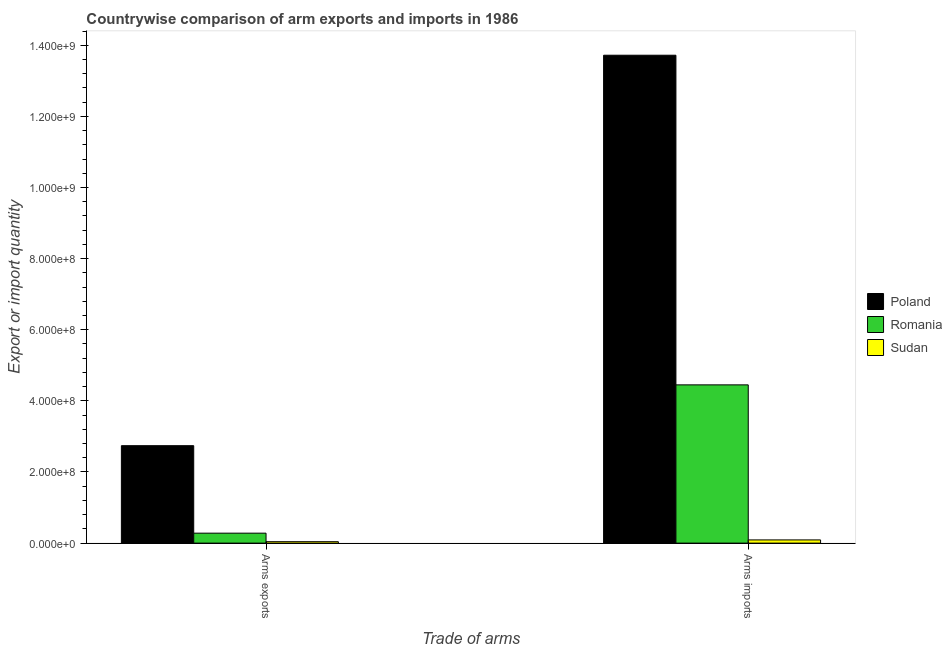How many different coloured bars are there?
Make the answer very short. 3. How many groups of bars are there?
Offer a very short reply. 2. How many bars are there on the 1st tick from the left?
Provide a succinct answer. 3. What is the label of the 2nd group of bars from the left?
Keep it short and to the point. Arms imports. What is the arms imports in Poland?
Keep it short and to the point. 1.37e+09. Across all countries, what is the maximum arms exports?
Provide a short and direct response. 2.74e+08. Across all countries, what is the minimum arms imports?
Provide a succinct answer. 9.00e+06. In which country was the arms imports maximum?
Your answer should be very brief. Poland. In which country was the arms imports minimum?
Your response must be concise. Sudan. What is the total arms imports in the graph?
Provide a succinct answer. 1.83e+09. What is the difference between the arms exports in Sudan and that in Poland?
Provide a short and direct response. -2.70e+08. What is the difference between the arms imports in Romania and the arms exports in Poland?
Your answer should be compact. 1.71e+08. What is the average arms exports per country?
Your answer should be compact. 1.02e+08. What is the difference between the arms exports and arms imports in Sudan?
Offer a terse response. -5.00e+06. What is the ratio of the arms imports in Romania to that in Poland?
Provide a short and direct response. 0.32. Is the arms exports in Sudan less than that in Poland?
Offer a very short reply. Yes. In how many countries, is the arms imports greater than the average arms imports taken over all countries?
Offer a very short reply. 1. What does the 3rd bar from the left in Arms exports represents?
Ensure brevity in your answer.  Sudan. What does the 2nd bar from the right in Arms imports represents?
Provide a succinct answer. Romania. How many bars are there?
Make the answer very short. 6. Are all the bars in the graph horizontal?
Give a very brief answer. No. What is the difference between two consecutive major ticks on the Y-axis?
Your answer should be compact. 2.00e+08. Are the values on the major ticks of Y-axis written in scientific E-notation?
Give a very brief answer. Yes. Does the graph contain any zero values?
Give a very brief answer. No. Where does the legend appear in the graph?
Offer a very short reply. Center right. How are the legend labels stacked?
Your answer should be compact. Vertical. What is the title of the graph?
Give a very brief answer. Countrywise comparison of arm exports and imports in 1986. Does "Macedonia" appear as one of the legend labels in the graph?
Your response must be concise. No. What is the label or title of the X-axis?
Your answer should be compact. Trade of arms. What is the label or title of the Y-axis?
Your answer should be compact. Export or import quantity. What is the Export or import quantity of Poland in Arms exports?
Your answer should be compact. 2.74e+08. What is the Export or import quantity of Romania in Arms exports?
Your response must be concise. 2.80e+07. What is the Export or import quantity of Poland in Arms imports?
Provide a short and direct response. 1.37e+09. What is the Export or import quantity in Romania in Arms imports?
Give a very brief answer. 4.45e+08. What is the Export or import quantity in Sudan in Arms imports?
Provide a short and direct response. 9.00e+06. Across all Trade of arms, what is the maximum Export or import quantity in Poland?
Your answer should be compact. 1.37e+09. Across all Trade of arms, what is the maximum Export or import quantity of Romania?
Provide a short and direct response. 4.45e+08. Across all Trade of arms, what is the maximum Export or import quantity in Sudan?
Ensure brevity in your answer.  9.00e+06. Across all Trade of arms, what is the minimum Export or import quantity of Poland?
Your answer should be very brief. 2.74e+08. Across all Trade of arms, what is the minimum Export or import quantity in Romania?
Give a very brief answer. 2.80e+07. What is the total Export or import quantity of Poland in the graph?
Offer a terse response. 1.65e+09. What is the total Export or import quantity in Romania in the graph?
Make the answer very short. 4.73e+08. What is the total Export or import quantity of Sudan in the graph?
Provide a succinct answer. 1.30e+07. What is the difference between the Export or import quantity in Poland in Arms exports and that in Arms imports?
Your answer should be very brief. -1.10e+09. What is the difference between the Export or import quantity of Romania in Arms exports and that in Arms imports?
Provide a succinct answer. -4.17e+08. What is the difference between the Export or import quantity of Sudan in Arms exports and that in Arms imports?
Ensure brevity in your answer.  -5.00e+06. What is the difference between the Export or import quantity in Poland in Arms exports and the Export or import quantity in Romania in Arms imports?
Your answer should be very brief. -1.71e+08. What is the difference between the Export or import quantity in Poland in Arms exports and the Export or import quantity in Sudan in Arms imports?
Your response must be concise. 2.65e+08. What is the difference between the Export or import quantity in Romania in Arms exports and the Export or import quantity in Sudan in Arms imports?
Make the answer very short. 1.90e+07. What is the average Export or import quantity in Poland per Trade of arms?
Your response must be concise. 8.23e+08. What is the average Export or import quantity of Romania per Trade of arms?
Make the answer very short. 2.36e+08. What is the average Export or import quantity of Sudan per Trade of arms?
Your answer should be compact. 6.50e+06. What is the difference between the Export or import quantity in Poland and Export or import quantity in Romania in Arms exports?
Give a very brief answer. 2.46e+08. What is the difference between the Export or import quantity in Poland and Export or import quantity in Sudan in Arms exports?
Your answer should be compact. 2.70e+08. What is the difference between the Export or import quantity of Romania and Export or import quantity of Sudan in Arms exports?
Keep it short and to the point. 2.40e+07. What is the difference between the Export or import quantity in Poland and Export or import quantity in Romania in Arms imports?
Give a very brief answer. 9.27e+08. What is the difference between the Export or import quantity in Poland and Export or import quantity in Sudan in Arms imports?
Provide a short and direct response. 1.36e+09. What is the difference between the Export or import quantity in Romania and Export or import quantity in Sudan in Arms imports?
Make the answer very short. 4.36e+08. What is the ratio of the Export or import quantity of Poland in Arms exports to that in Arms imports?
Your response must be concise. 0.2. What is the ratio of the Export or import quantity in Romania in Arms exports to that in Arms imports?
Your response must be concise. 0.06. What is the ratio of the Export or import quantity of Sudan in Arms exports to that in Arms imports?
Your answer should be very brief. 0.44. What is the difference between the highest and the second highest Export or import quantity in Poland?
Offer a terse response. 1.10e+09. What is the difference between the highest and the second highest Export or import quantity of Romania?
Make the answer very short. 4.17e+08. What is the difference between the highest and the lowest Export or import quantity of Poland?
Give a very brief answer. 1.10e+09. What is the difference between the highest and the lowest Export or import quantity in Romania?
Make the answer very short. 4.17e+08. 